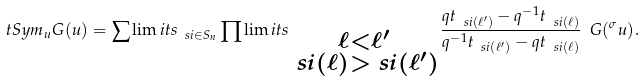<formula> <loc_0><loc_0><loc_500><loc_500>\ t S y m _ { u } G ( u ) = \sum \lim i t s _ { \ s i \in S _ { n } } \prod \lim i t s _ { \substack { \ell < \ell ^ { \prime } \\ \ s i ( \ell ) > \ s i ( \ell ^ { \prime } ) } } \frac { q t _ { \ s i ( \ell ^ { \prime } ) } - q ^ { - 1 } t _ { \ s i ( \ell ) } } { q ^ { - 1 } t _ { \ s i ( \ell ^ { \prime } ) } - q t _ { \ s i ( \ell ) } } \ G ( ^ { \sigma } u ) .</formula> 